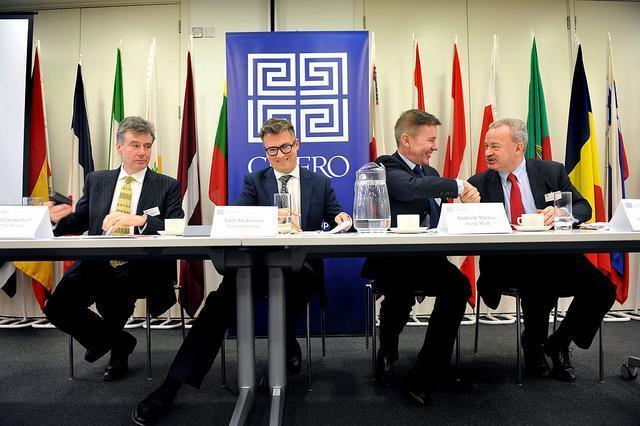How many people at the table?
Give a very brief answer. 4. How many people can you see?
Give a very brief answer. 4. How many microwaves are in the picture?
Give a very brief answer. 0. 